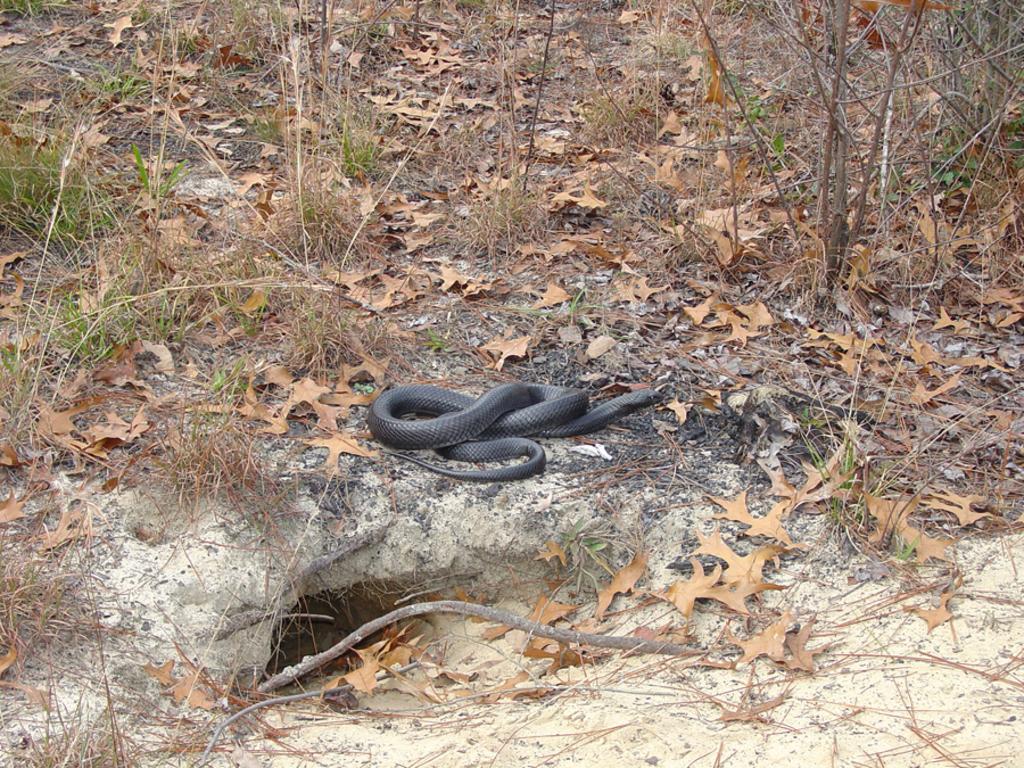How would you summarize this image in a sentence or two? In this picture we can see a snake and dried leaves on the ground and in the background we can see plants. 